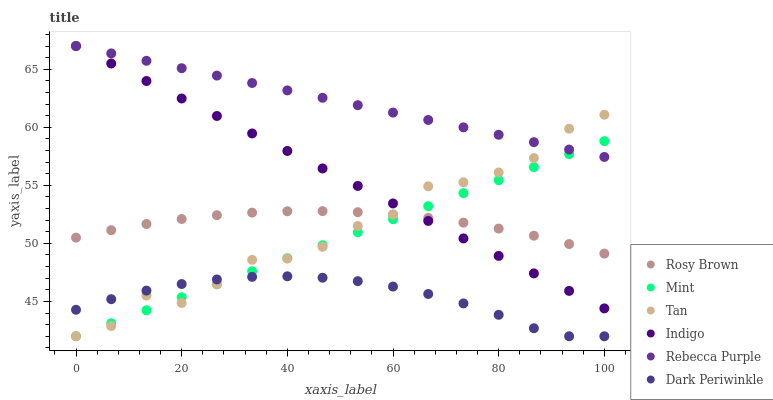Does Dark Periwinkle have the minimum area under the curve?
Answer yes or no. Yes. Does Rebecca Purple have the maximum area under the curve?
Answer yes or no. Yes. Does Rosy Brown have the minimum area under the curve?
Answer yes or no. No. Does Rosy Brown have the maximum area under the curve?
Answer yes or no. No. Is Mint the smoothest?
Answer yes or no. Yes. Is Tan the roughest?
Answer yes or no. Yes. Is Rosy Brown the smoothest?
Answer yes or no. No. Is Rosy Brown the roughest?
Answer yes or no. No. Does Tan have the lowest value?
Answer yes or no. Yes. Does Rosy Brown have the lowest value?
Answer yes or no. No. Does Rebecca Purple have the highest value?
Answer yes or no. Yes. Does Rosy Brown have the highest value?
Answer yes or no. No. Is Rosy Brown less than Rebecca Purple?
Answer yes or no. Yes. Is Indigo greater than Dark Periwinkle?
Answer yes or no. Yes. Does Indigo intersect Tan?
Answer yes or no. Yes. Is Indigo less than Tan?
Answer yes or no. No. Is Indigo greater than Tan?
Answer yes or no. No. Does Rosy Brown intersect Rebecca Purple?
Answer yes or no. No. 